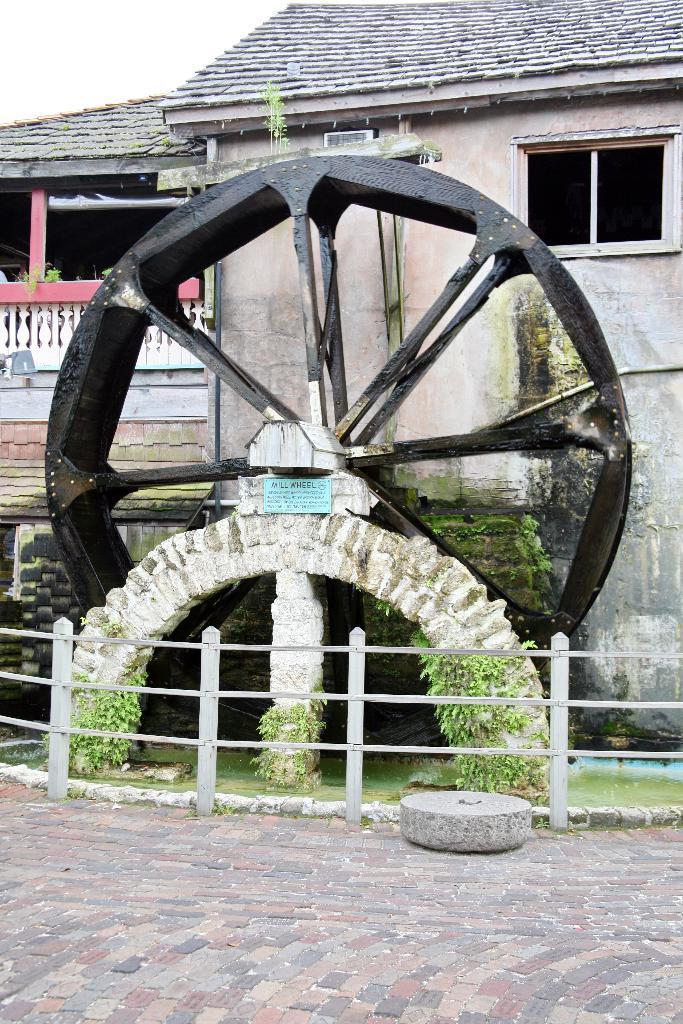Please provide a concise description of this image. In this image we can see the depiction of a wheel. Behind the wheel we can see the house. At the bottom we can see the fence, plants and also the path. 